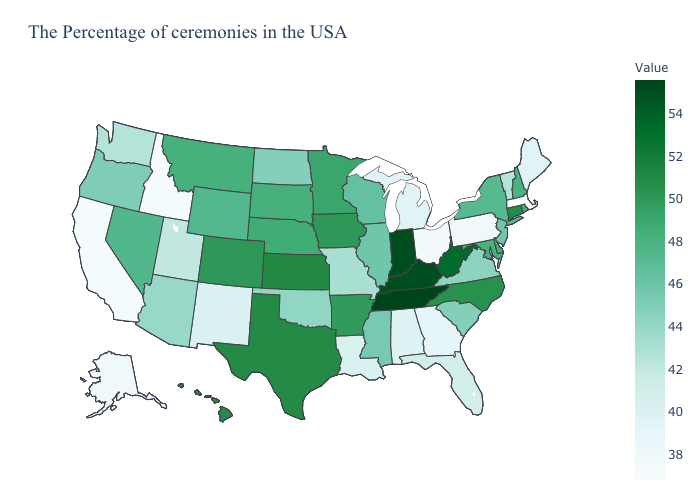Does Tennessee have the highest value in the USA?
Short answer required. Yes. Does Rhode Island have the highest value in the Northeast?
Quick response, please. No. Does Nebraska have a higher value than Pennsylvania?
Be succinct. Yes. Does Alaska have the highest value in the West?
Be succinct. No. Does South Dakota have a lower value than Texas?
Quick response, please. Yes. Among the states that border Florida , does Georgia have the lowest value?
Short answer required. Yes. Does the map have missing data?
Write a very short answer. No. Which states have the lowest value in the MidWest?
Short answer required. Ohio. 